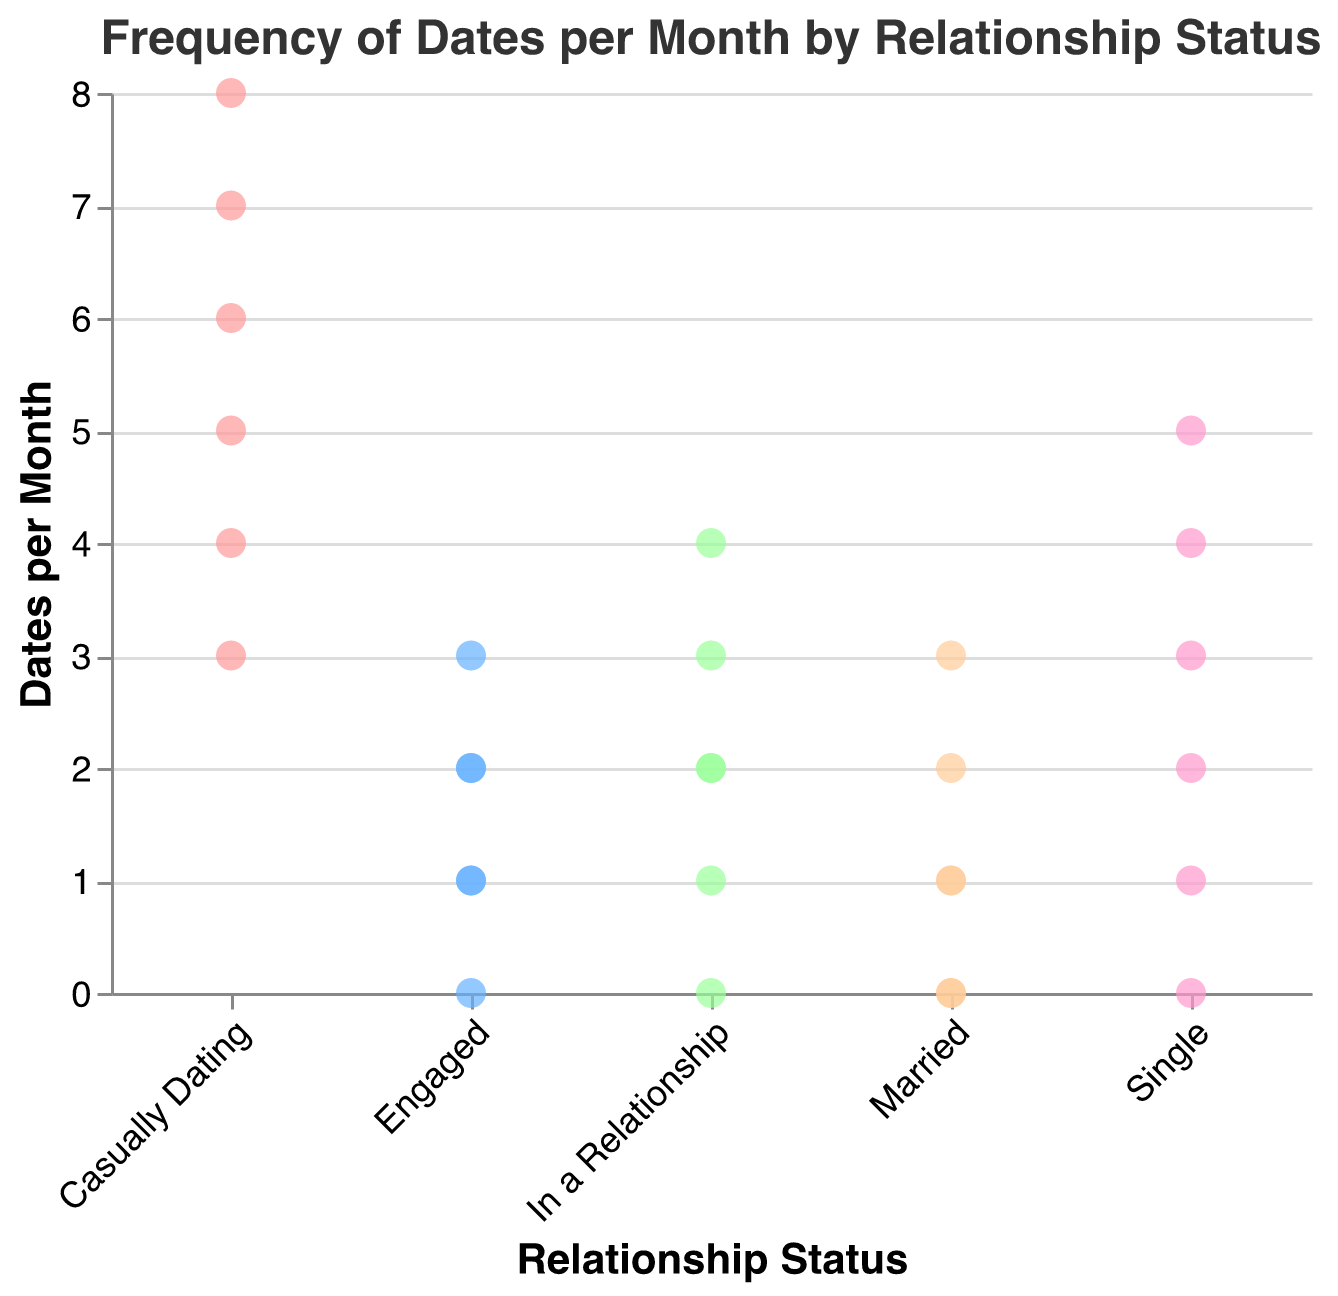What is the title of the plot? The title is displayed at the top of the plot to give an overview of the data being visualized.
Answer: Frequency of Dates per Month by Relationship Status Which relationship status has the widest range of dates per month? By observing the vertical spread of data points for each relationship status, note which status has the most extended range from lowest to highest values.
Answer: Casually Dating How many data points are there for individuals who are 'Single'? Count the number of points directly above the 'Single' label on the x-axis.
Answer: 6 What is the median number of dates per month for individuals who are 'Engaged'? First, arrange the 'Engaged' data points in ascending order (0, 1, 1, 2, 2, 3). The median is the middle value in this ordered list.
Answer: 1.5 Which relationship status has the lowest maximum number of dates per month? Find the highest vertical position for each relationship status, then determine which status has the lowest of these highest values.
Answer: Engaged and Married Compare the average number of dates per month between individuals who are 'Single' and those who are 'Married'. Calculate the average for both groups. Single: (2+4+1+3+5+0)/6 = 2.5. Married: (0+1+2+0+1+3)/6 = 1.17. Compare the results.
Answer: Single has a higher average What is the most common number of dates per month for individuals who are 'In a Relationship'? Identify the number of dates that appears most frequently for this group by looking at the vertical clustering of points.
Answer: 2 Which group has the least variability in the number of dates per month? Variability refers to the spread or range of the data points. Look for the group with the smallest range between its highest and lowest values.
Answer: Engaged Are there any relationship statuses where someone has zero dates per month? Check for data points at the y-axis value of 0 across each relationship status.
Answer: Yes, Single, In a Relationship, Engaged, Married 